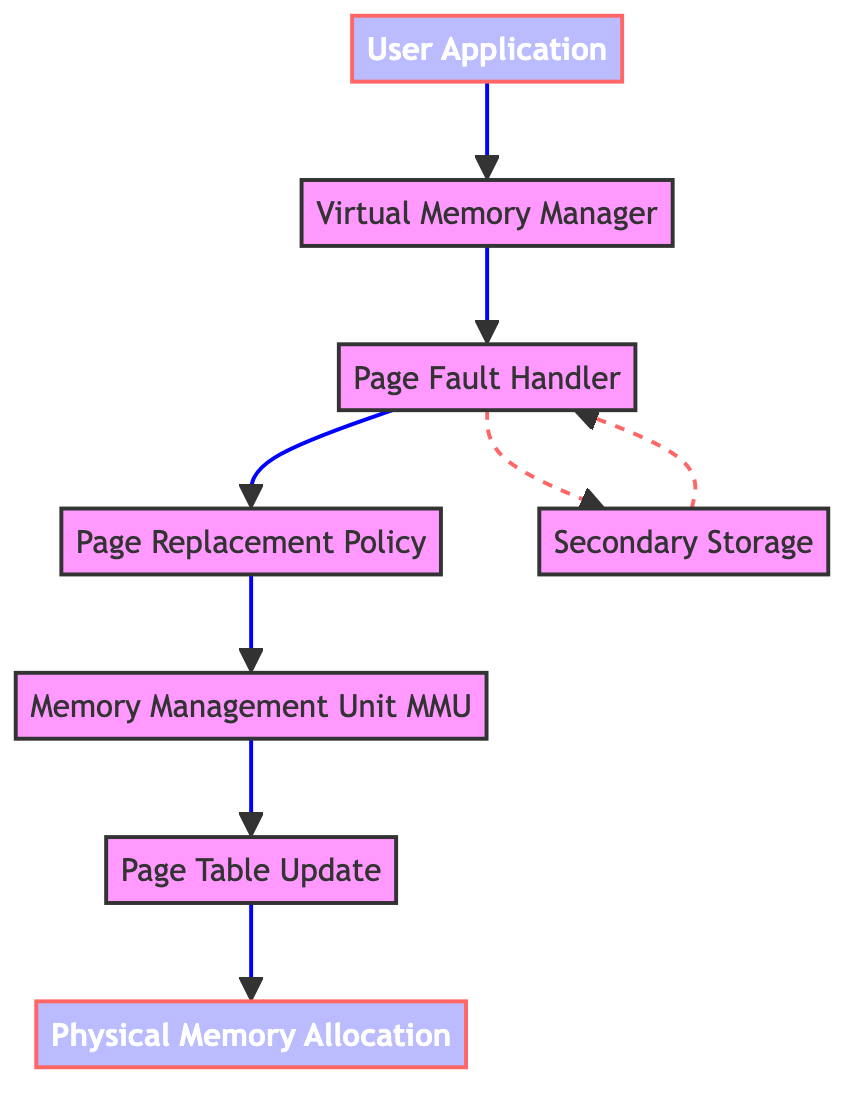What is the starting point of the flow? The flow begins at the "User Application" node, which represents the software program requesting memory allocation. This is the first element in the sequence of actions described.
Answer: User Application How many nodes are in the diagram? The diagram contains eight nodes: User Application, Virtual Memory Manager, Page Fault Handler, Page Replacement Policy, Memory Management Unit (MMU), Page Table Update, Physical Memory Allocation, and Secondary Storage. By counting each distinct labeled element, we arrive at eight.
Answer: Eight Which node directly follows the Virtual Memory Manager? The node immediately following the "Virtual Memory Manager" is the "Page Fault Handler." This is evident from the directed flow indicated in the diagram.
Answer: Page Fault Handler What is the role of the Memory Management Unit (MMU)? The "Memory Management Unit (MMU)" is responsible for translating virtual addresses to physical addresses, which is essential for memory management in the system. This is explicitly mentioned in its description.
Answer: Translating virtual addresses to physical addresses From which node does the flow diverge to Secondary Storage? The flow diverges to "Secondary Storage" from the "Page Fault Handler." It is indicated in the diagram that when a page fault occurs, there is a connection to the secondary storage for page allocation.
Answer: Page Fault Handler What happens when physical memory is full? When physical memory is full, the "Page Replacement Policy" comes into play, determining which pages should be swapped out to make room for new pages in memory. The diagram shows that this decision point follows the page fault handling.
Answer: Page Replacement Policy What is the last step in the flow of memory management? The last step in the flow is "Physical Memory Allocation," which represents the actual assignment of memory frames to the pages allocated for the user application. It is the final action in the series of memory management requests.
Answer: Physical Memory Allocation How does the flow from Secondary Storage back to the Page Fault Handler operate? The flow indicates a dashed line from "Secondary Storage" back to the "Page Fault Handler," suggesting there is a feedback mechanism for handling situations when additional pages must be retrieved from secondary storage. This forms a necessary loop in case of page faults.
Answer: Feedback mechanism What is indicated by the dashed lines in the diagram? The dashed lines in the diagram indicate non-linear connections, specifically the alternative flow path taken between the "Page Fault Handler" and "Secondary Storage." This signifies an external resource interaction when memory needs to be allocated from secondary storage.
Answer: External resource interaction 